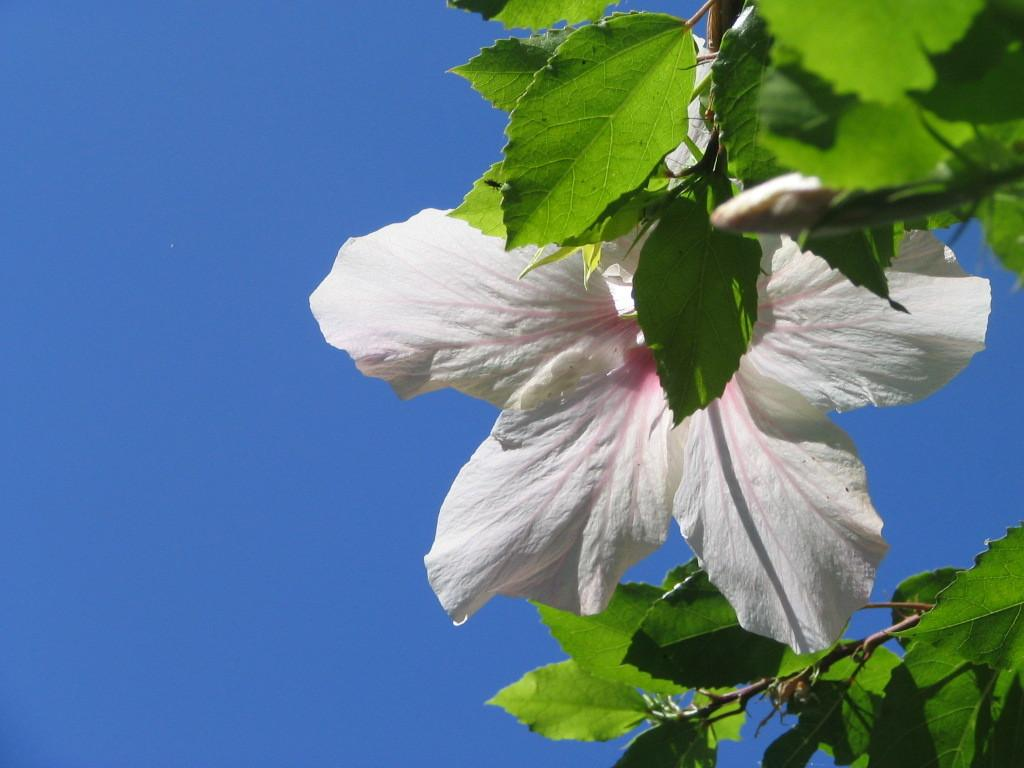What type of flowers can be seen in the image? There are white color flowers in the image. What else is present in the image besides the flowers? There are leaves in the image. What color is the sky in the image? The sky is blue in color. Can you see any cracks in the flowers in the image? There are no cracks visible in the flowers in the image. What beliefs do the flowers in the image hold? The flowers in the image do not hold any beliefs, as they are inanimate objects. 